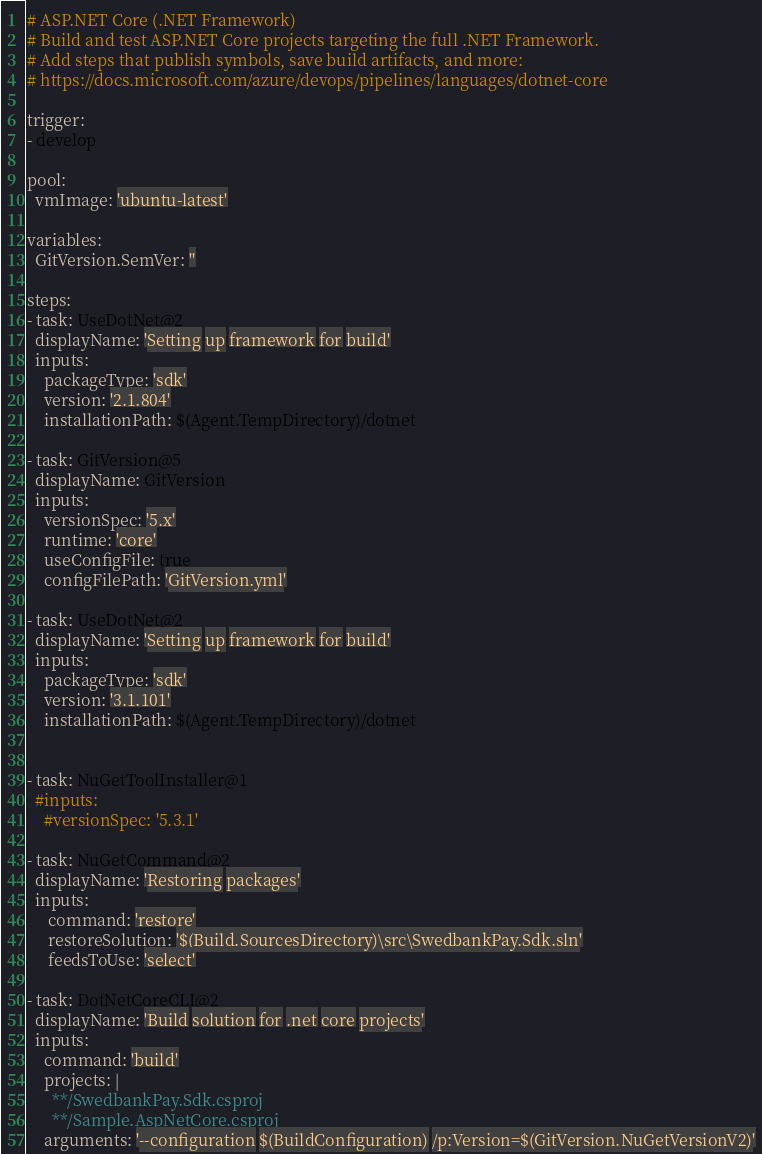<code> <loc_0><loc_0><loc_500><loc_500><_YAML_># ASP.NET Core (.NET Framework)
# Build and test ASP.NET Core projects targeting the full .NET Framework.
# Add steps that publish symbols, save build artifacts, and more:
# https://docs.microsoft.com/azure/devops/pipelines/languages/dotnet-core

trigger:
- develop

pool:
  vmImage: 'ubuntu-latest'

variables:
  GitVersion.SemVer: ''

steps:
- task: UseDotNet@2
  displayName: 'Setting up framework for build'
  inputs:
    packageType: 'sdk'
    version: '2.1.804'
    installationPath: $(Agent.TempDirectory)/dotnet

- task: GitVersion@5
  displayName: GitVersion
  inputs:
    versionSpec: '5.x'
    runtime: 'core'
    useConfigFile: true
    configFilePath: 'GitVersion.yml'

- task: UseDotNet@2
  displayName: 'Setting up framework for build'
  inputs:
    packageType: 'sdk'
    version: '3.1.101'
    installationPath: $(Agent.TempDirectory)/dotnet


- task: NuGetToolInstaller@1
  #inputs:
    #versionSpec: '5.3.1'

- task: NuGetCommand@2
  displayName: 'Restoring packages'
  inputs:
     command: 'restore'
     restoreSolution: '$(Build.SourcesDirectory)\src\SwedbankPay.Sdk.sln'
     feedsToUse: 'select'

- task: DotNetCoreCLI@2
  displayName: 'Build solution for .net core projects'
  inputs:
    command: 'build'
    projects: |
      **/SwedbankPay.Sdk.csproj
      **/Sample.AspNetCore.csproj
    arguments: '--configuration $(BuildConfiguration) /p:Version=$(GitVersion.NuGetVersionV2)'
</code> 